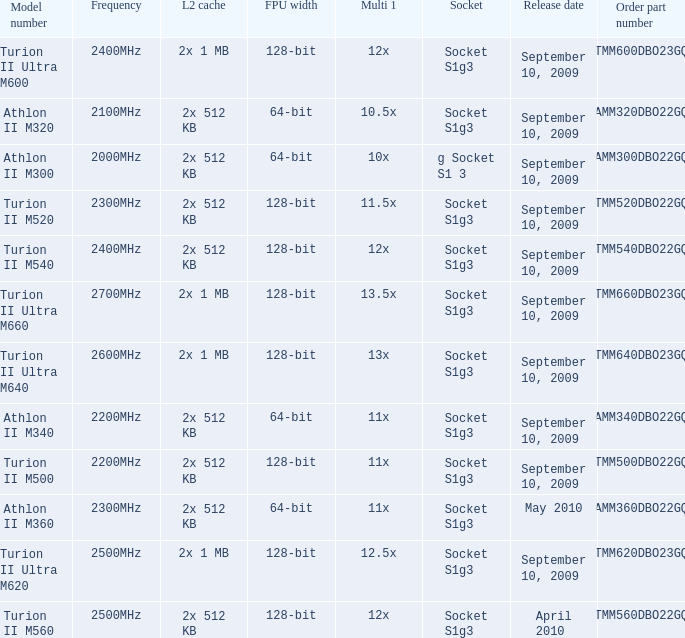What is the socket with an order part number of amm300dbo22gq and a September 10, 2009 release date? G socket s1 3. 